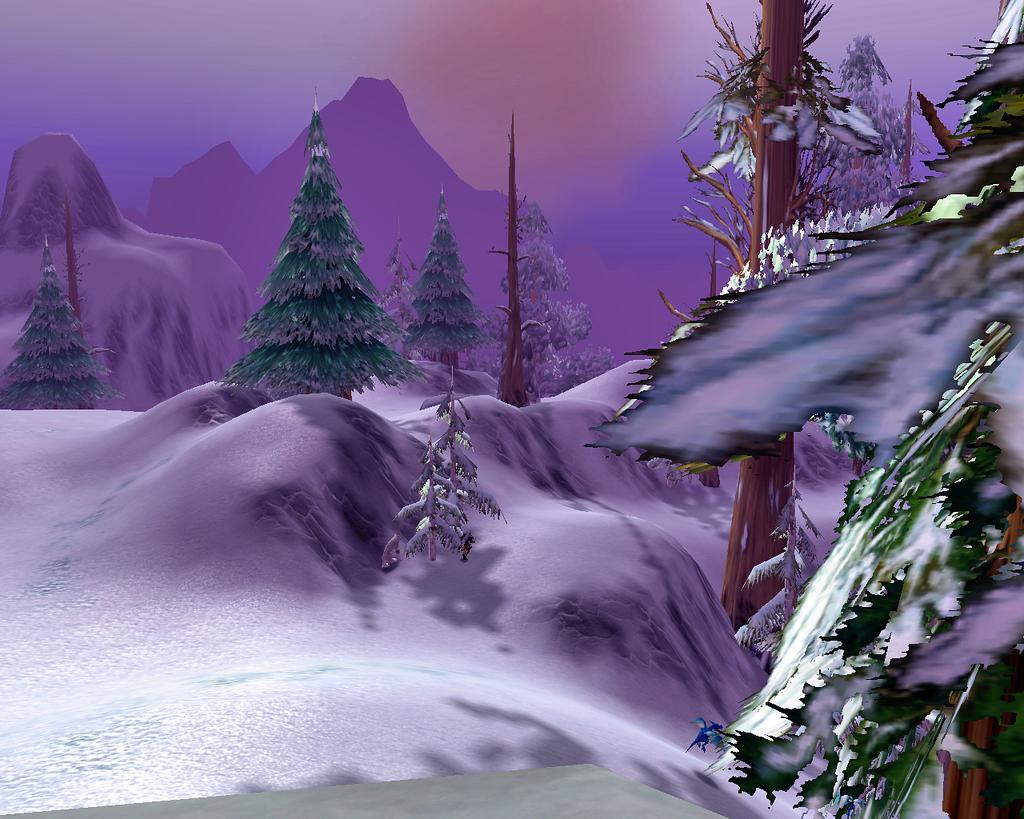Can you describe this image briefly? By seeing image we can say it is an animated picture. In the foreground we can see snow. In the middle of the image we can see trees which are similar to a Christmas tree. On the top of the image we can see snow mountains. 